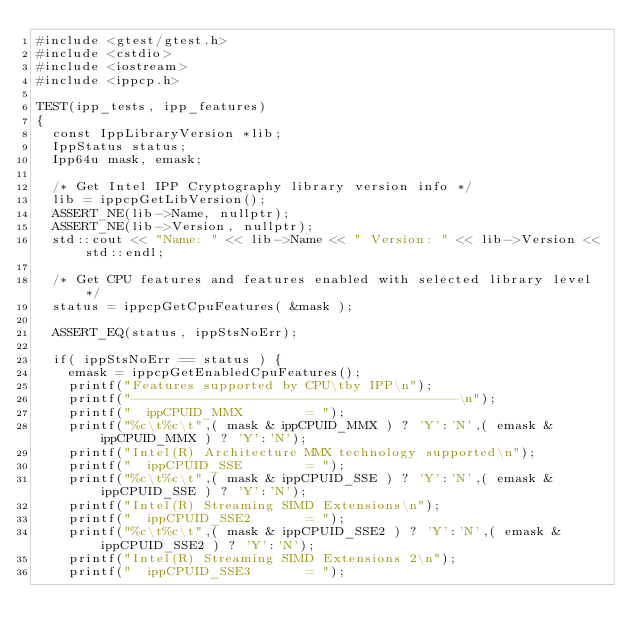<code> <loc_0><loc_0><loc_500><loc_500><_C++_>#include <gtest/gtest.h>
#include <cstdio>
#include <iostream>
#include <ippcp.h>

TEST(ipp_tests, ipp_features)
{
	const IppLibraryVersion *lib;
	IppStatus status;
	Ipp64u mask, emask;

	/* Get Intel IPP Cryptography library version info */
	lib = ippcpGetLibVersion();
	ASSERT_NE(lib->Name, nullptr);
	ASSERT_NE(lib->Version, nullptr);
	std::cout << "Name: " << lib->Name << " Version: " << lib->Version << std::endl;

	/* Get CPU features and features enabled with selected library level */
	status = ippcpGetCpuFeatures( &mask );

	ASSERT_EQ(status, ippStsNoErr);

	if( ippStsNoErr == status ) {
		emask = ippcpGetEnabledCpuFeatures();
		printf("Features supported by CPU\tby IPP\n");
		printf("-----------------------------------------\n");
		printf("  ippCPUID_MMX        = ");
		printf("%c\t%c\t",( mask & ippCPUID_MMX ) ? 'Y':'N',( emask & ippCPUID_MMX ) ? 'Y':'N');
		printf("Intel(R) Architecture MMX technology supported\n");
		printf("  ippCPUID_SSE        = ");
		printf("%c\t%c\t",( mask & ippCPUID_SSE ) ? 'Y':'N',( emask & ippCPUID_SSE ) ? 'Y':'N');
		printf("Intel(R) Streaming SIMD Extensions\n");
		printf("  ippCPUID_SSE2       = ");
		printf("%c\t%c\t",( mask & ippCPUID_SSE2 ) ? 'Y':'N',( emask & ippCPUID_SSE2 ) ? 'Y':'N');
		printf("Intel(R) Streaming SIMD Extensions 2\n");
		printf("  ippCPUID_SSE3       = ");</code> 